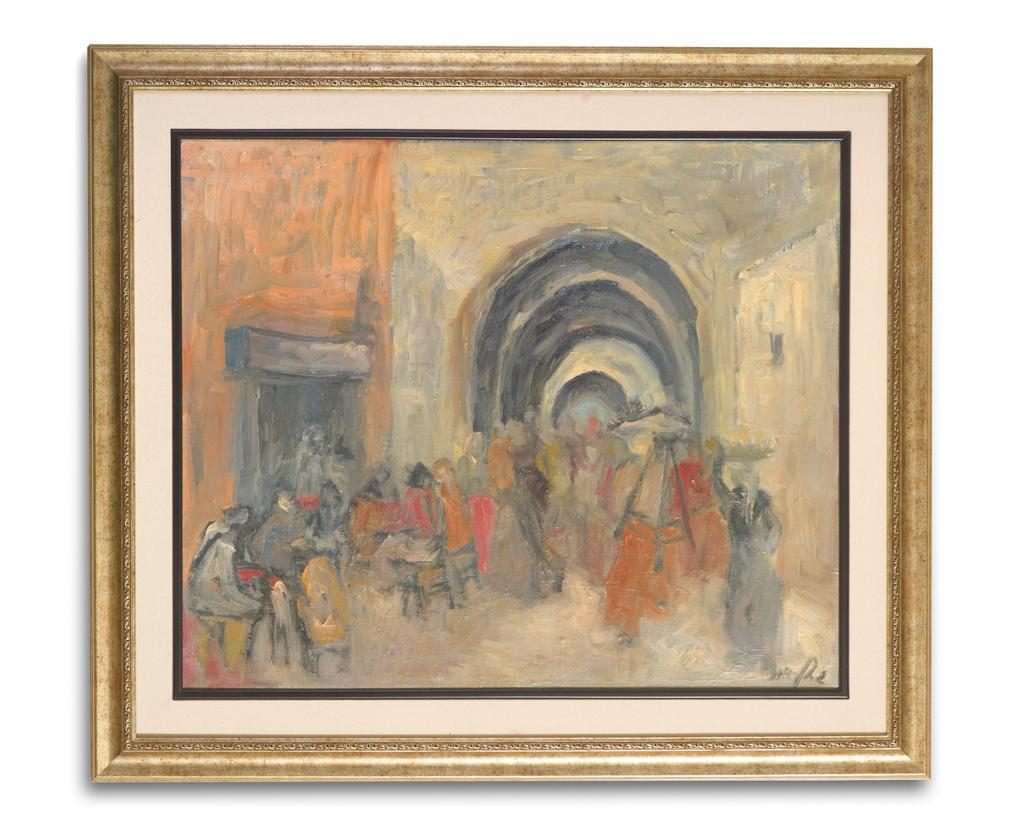What is the main object in the image? There is a frame in the image. What is inside the frame? The frame contains a painting. What color is the background of the image? The background of the image is white. Can you see a cat playing with a blade in the image? No, there is no cat or blade present in the image. What type of soap is being used to clean the painting in the image? There is no soap or cleaning activity depicted in the image; it only shows a frame with a painting and a white background. 